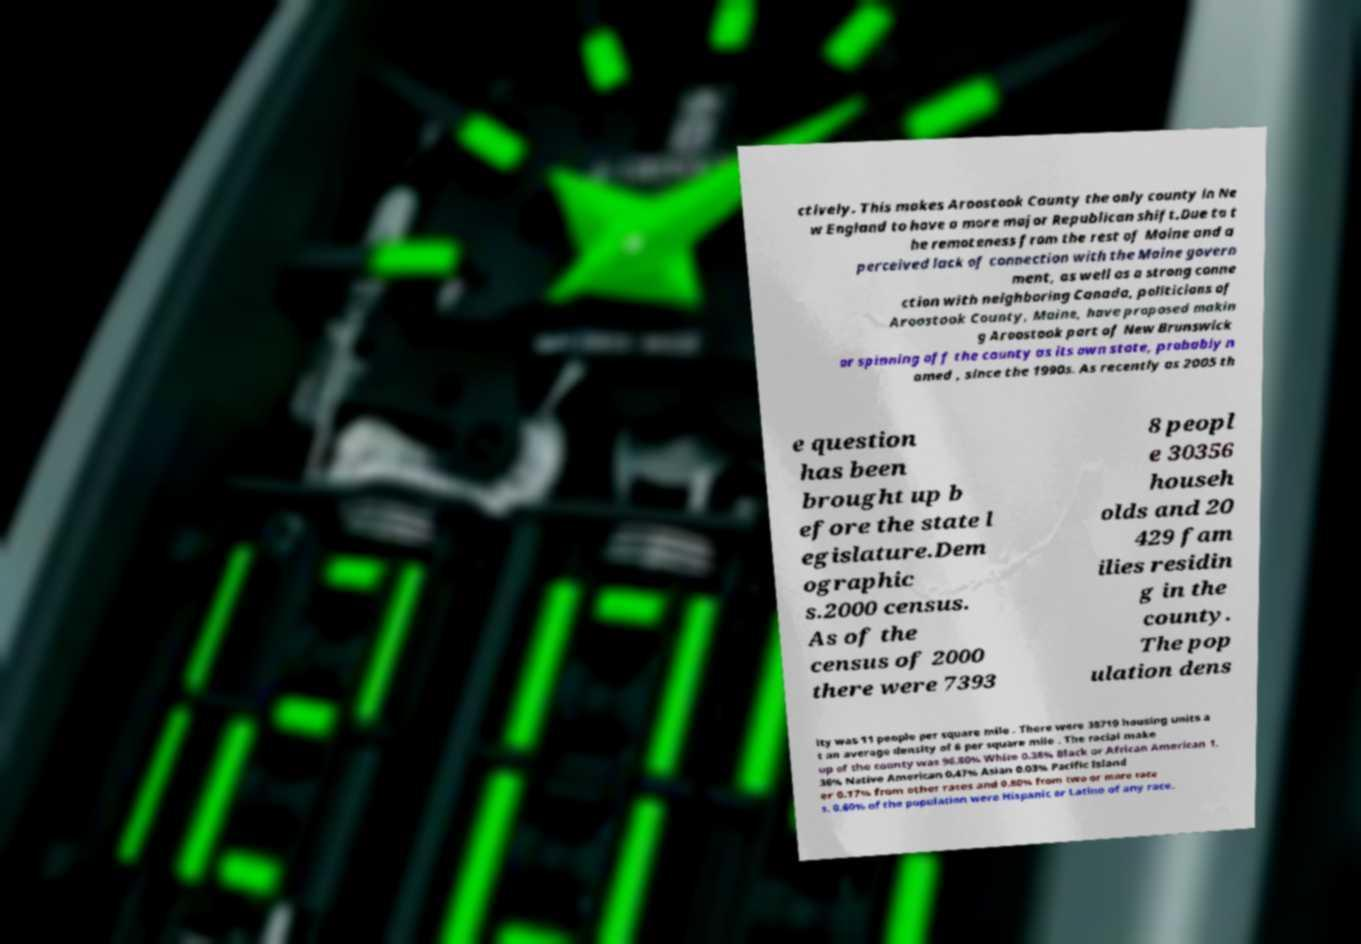Can you read and provide the text displayed in the image?This photo seems to have some interesting text. Can you extract and type it out for me? ctively. This makes Aroostook County the only county in Ne w England to have a more major Republican shift.Due to t he remoteness from the rest of Maine and a perceived lack of connection with the Maine govern ment, as well as a strong conne ction with neighboring Canada, politicians of Aroostook County, Maine, have proposed makin g Aroostook part of New Brunswick or spinning off the county as its own state, probably n amed , since the 1990s. As recently as 2005 th e question has been brought up b efore the state l egislature.Dem ographic s.2000 census. As of the census of 2000 there were 7393 8 peopl e 30356 househ olds and 20 429 fam ilies residin g in the county. The pop ulation dens ity was 11 people per square mile . There were 38719 housing units a t an average density of 6 per square mile . The racial make up of the county was 96.80% White 0.38% Black or African American 1. 36% Native American 0.47% Asian 0.03% Pacific Island er 0.17% from other races and 0.80% from two or more race s. 0.60% of the population were Hispanic or Latino of any race. 